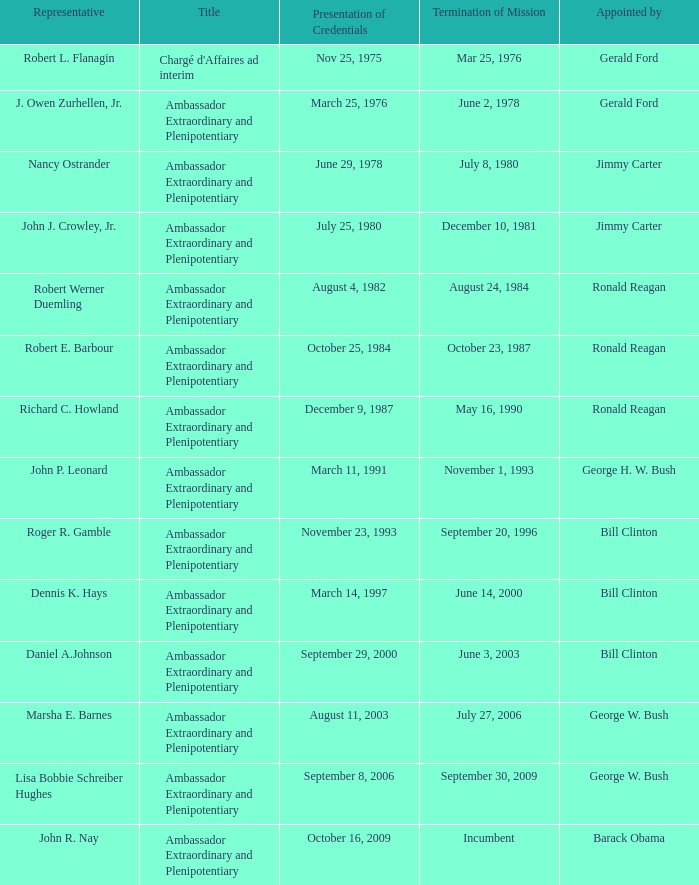Which representative was the Ambassador Extraordinary and Plenipotentiary and had a Termination of Mission date September 20, 1996? Roger R. Gamble. 